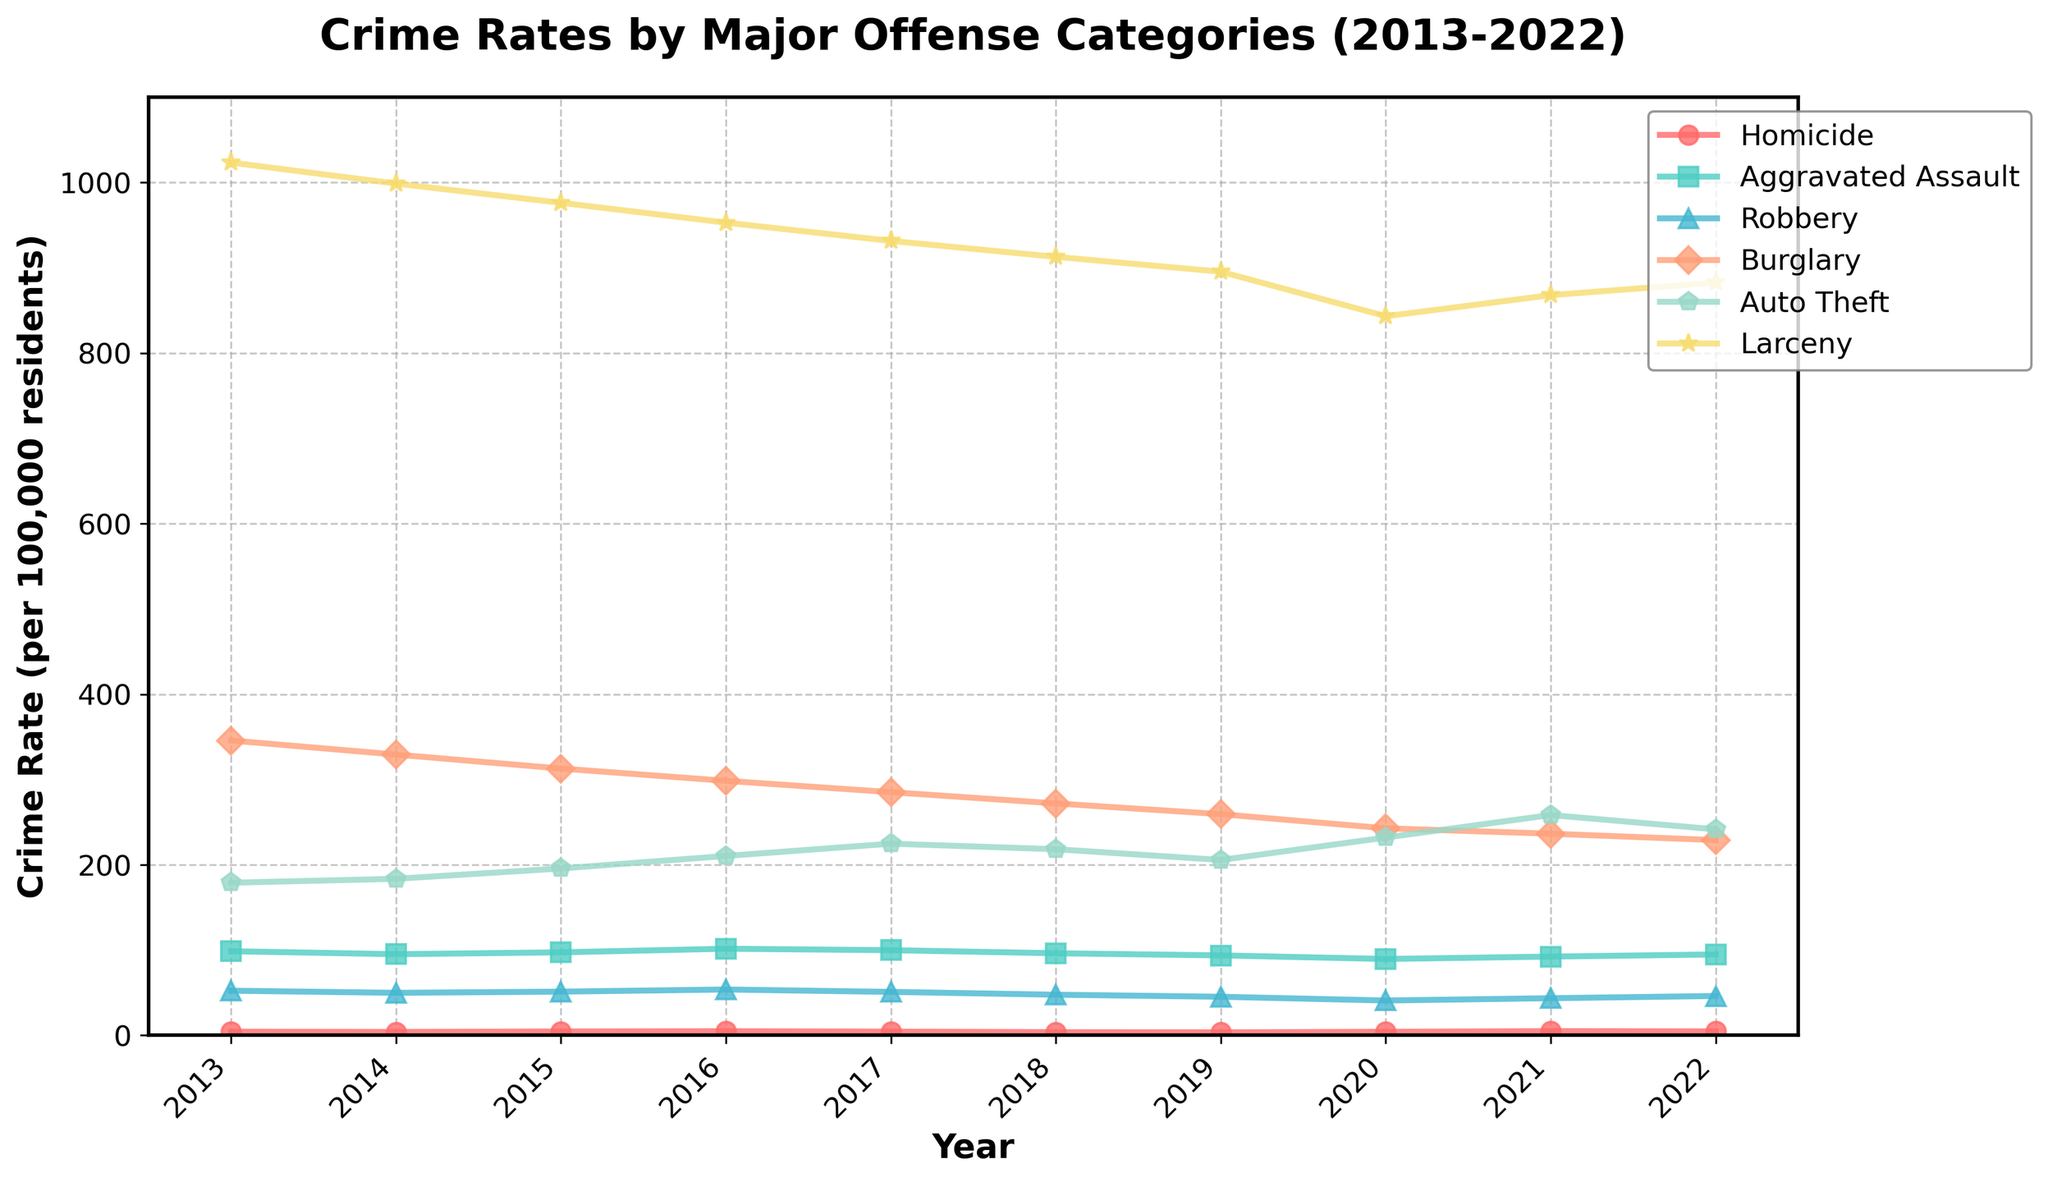Which crime category had the highest rate in 2022? Look at the endpoint on the line corresponding to 2022 for each category and compare their heights. The line representing Larceny is the highest.
Answer: Larceny By how much did the rate of Burglary decrease from 2013 to 2022? Subtract the Burglary rate in 2022 (228.9) from the Burglary rate in 2013 (345.7). The difference is 345.7 - 228.9.
Answer: 116.8 Which year experienced the highest rate of Auto Theft? Identify the peak point on the Auto Theft line and check its corresponding year label. The highest point is at 2021.
Answer: 2021 Compare the rate of Homicide and Aggravated Assault in 2013. Which was higher and by how much? Compare the heights for 2013 for both lines. The rate of Homicide was 4.2 and Aggravated Assault was 98.6. Subtract the Homicide rate from the Aggravated Assault rate: 98.6 - 4.2.
Answer: Aggravated Assault by 94.4 What is the average rate of Robbery from 2015 to 2017? Sum the Robbery rates from 2015 to 2017 and divide by the number of years. (51.2 + 53.7 + 50.9) / 3 = 51.93
Answer: 51.93 Which crime category showed the most significant drop between any two consecutive years? Identify the biggest drop between any two points for all categories. The largest drop is for Auto Theft between 2021 (258.3) and 2022 (241.5).
Answer: Auto Theft Between 2020 and 2021, which offense category showed an increase, and what was the value? Check the points of change from 2020 to 2021 for each category. The rates that increased are Homicide, Aggravated Assault, and Robbery. The increase values are 0.8, 2.8, and 2.7 respectively.
Answer: Homicide by 0.8, Aggravated Assault by 2.8, Robbery by 2.7 What is the total crime rate for all categories in 2017? Sum the rates of all categories for 2017. 4.3 + 99.8 + 50.9 + 285.1 + 224.7 + 931.5
Answer: 1596.3 Which category consistently had the lowest crime rate over the decade? Examine each line and determine which stays at the lowest position throughout. The Homicide line is consistently the lowest.
Answer: Homicide In which year did the rate of Aggravated Assault peak? Identify the highest point on the Aggravated Assault line and its corresponding year label. The highest point is at 2016.
Answer: 2016 